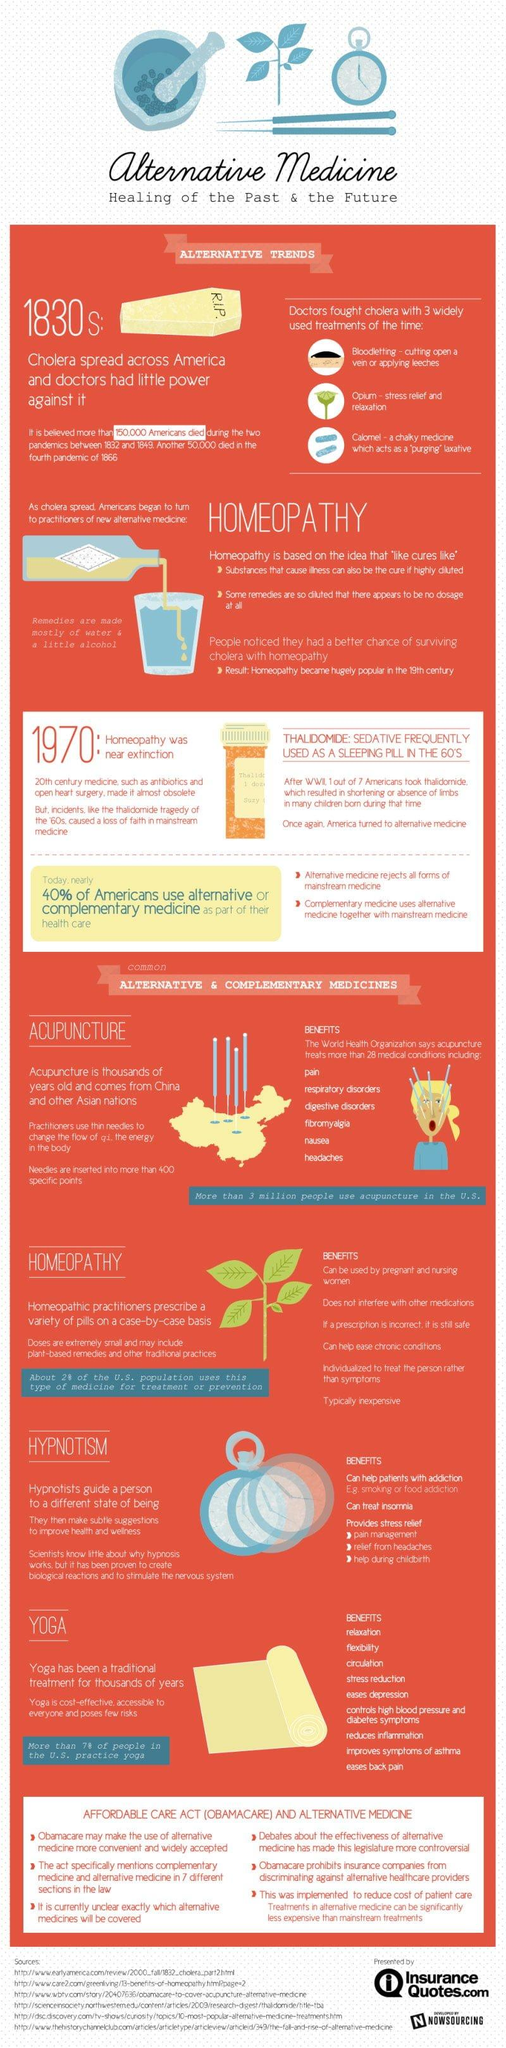Highlight a few significant elements in this photo. There are six benefits associated with homeopathy. The color of the yoga mat is yellow. The inscription on the coffin reads 'R.I.P.' Other alternative and complementary medicines, such as acupuncture, homeopathy, and hypnotism, exist beyond yoga. Acupuncture is a treatment where practitioners use thin needles to manipulate the flow of qi, or the energy in the body, in order to promote healing and improve overall health. 